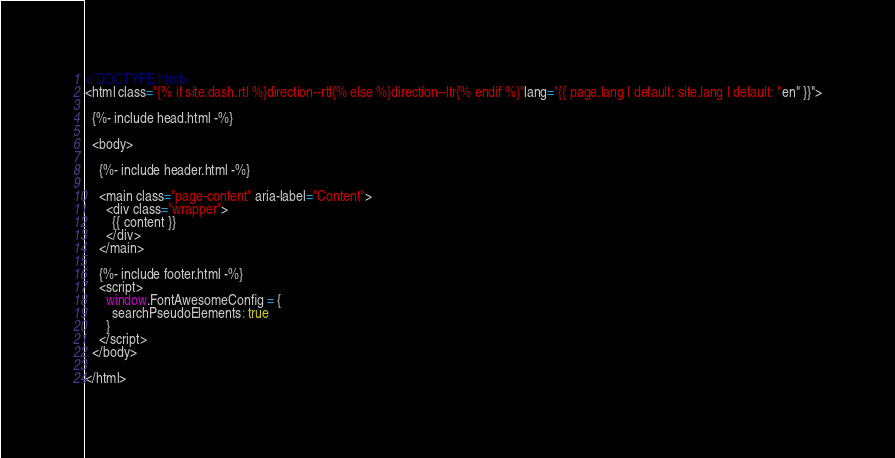<code> <loc_0><loc_0><loc_500><loc_500><_HTML_><!DOCTYPE html>
<html class="{% if site.dash.rtl %}direction--rtl{% else %}direction--ltr{% endif %}"lang="{{ page.lang | default: site.lang | default: "en" }}">

  {%- include head.html -%}

  <body>

    {%- include header.html -%}

    <main class="page-content" aria-label="Content">
      <div class="wrapper">
        {{ content }}
      </div>
    </main>

    {%- include footer.html -%}
    <script>
      window.FontAwesomeConfig = {
        searchPseudoElements: true
      }
    </script>
  </body>

</html>
</code> 